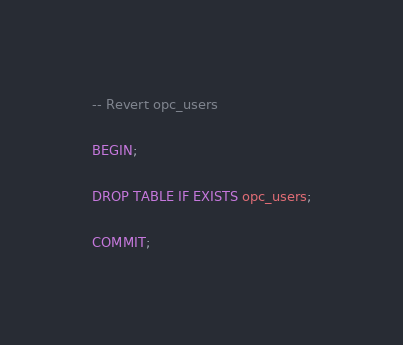<code> <loc_0><loc_0><loc_500><loc_500><_SQL_>-- Revert opc_users

BEGIN;

DROP TABLE IF EXISTS opc_users;

COMMIT;
</code> 